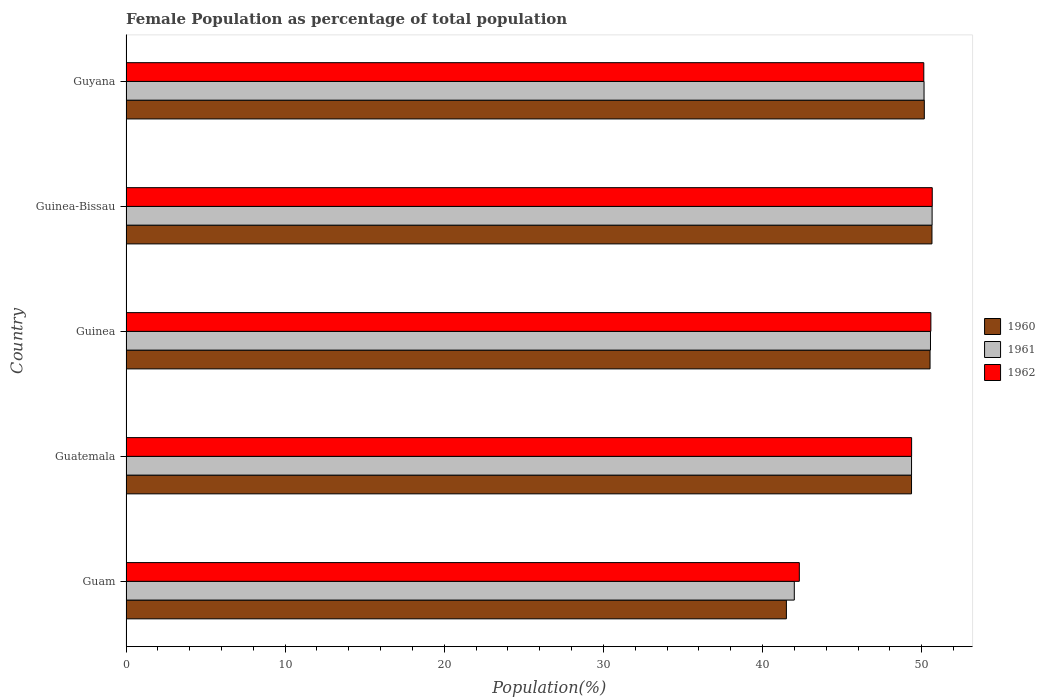How many groups of bars are there?
Ensure brevity in your answer.  5. How many bars are there on the 2nd tick from the bottom?
Give a very brief answer. 3. What is the label of the 3rd group of bars from the top?
Ensure brevity in your answer.  Guinea. What is the female population in in 1960 in Guam?
Your answer should be very brief. 41.5. Across all countries, what is the maximum female population in in 1962?
Your answer should be very brief. 50.66. Across all countries, what is the minimum female population in in 1961?
Offer a very short reply. 42. In which country was the female population in in 1962 maximum?
Your answer should be compact. Guinea-Bissau. In which country was the female population in in 1960 minimum?
Give a very brief answer. Guam. What is the total female population in in 1960 in the graph?
Provide a short and direct response. 242.2. What is the difference between the female population in in 1962 in Guatemala and that in Guyana?
Ensure brevity in your answer.  -0.77. What is the difference between the female population in in 1960 in Guam and the female population in in 1962 in Guinea?
Your answer should be compact. -9.08. What is the average female population in in 1962 per country?
Your response must be concise. 48.61. What is the difference between the female population in in 1961 and female population in in 1960 in Guam?
Provide a short and direct response. 0.5. What is the ratio of the female population in in 1961 in Guam to that in Guinea-Bissau?
Your answer should be very brief. 0.83. Is the female population in in 1962 in Guinea-Bissau less than that in Guyana?
Ensure brevity in your answer.  No. Is the difference between the female population in in 1961 in Guinea-Bissau and Guyana greater than the difference between the female population in in 1960 in Guinea-Bissau and Guyana?
Offer a very short reply. Yes. What is the difference between the highest and the second highest female population in in 1962?
Offer a terse response. 0.09. What is the difference between the highest and the lowest female population in in 1962?
Your answer should be compact. 8.35. Is the sum of the female population in in 1961 in Guinea and Guyana greater than the maximum female population in in 1962 across all countries?
Make the answer very short. Yes. What does the 3rd bar from the bottom in Guatemala represents?
Provide a short and direct response. 1962. How many bars are there?
Keep it short and to the point. 15. Are all the bars in the graph horizontal?
Provide a succinct answer. Yes. What is the difference between two consecutive major ticks on the X-axis?
Your answer should be very brief. 10. Are the values on the major ticks of X-axis written in scientific E-notation?
Give a very brief answer. No. What is the title of the graph?
Offer a terse response. Female Population as percentage of total population. What is the label or title of the X-axis?
Your answer should be compact. Population(%). What is the label or title of the Y-axis?
Offer a very short reply. Country. What is the Population(%) in 1960 in Guam?
Make the answer very short. 41.5. What is the Population(%) of 1961 in Guam?
Ensure brevity in your answer.  42. What is the Population(%) in 1962 in Guam?
Provide a succinct answer. 42.31. What is the Population(%) in 1960 in Guatemala?
Offer a terse response. 49.36. What is the Population(%) in 1961 in Guatemala?
Ensure brevity in your answer.  49.36. What is the Population(%) in 1962 in Guatemala?
Offer a very short reply. 49.37. What is the Population(%) in 1960 in Guinea?
Offer a terse response. 50.53. What is the Population(%) in 1961 in Guinea?
Your answer should be compact. 50.55. What is the Population(%) in 1962 in Guinea?
Your response must be concise. 50.58. What is the Population(%) in 1960 in Guinea-Bissau?
Ensure brevity in your answer.  50.65. What is the Population(%) of 1961 in Guinea-Bissau?
Your response must be concise. 50.66. What is the Population(%) of 1962 in Guinea-Bissau?
Your response must be concise. 50.66. What is the Population(%) of 1960 in Guyana?
Your answer should be compact. 50.17. What is the Population(%) in 1961 in Guyana?
Ensure brevity in your answer.  50.15. What is the Population(%) in 1962 in Guyana?
Your response must be concise. 50.13. Across all countries, what is the maximum Population(%) in 1960?
Give a very brief answer. 50.65. Across all countries, what is the maximum Population(%) of 1961?
Give a very brief answer. 50.66. Across all countries, what is the maximum Population(%) in 1962?
Ensure brevity in your answer.  50.66. Across all countries, what is the minimum Population(%) in 1960?
Your answer should be very brief. 41.5. Across all countries, what is the minimum Population(%) of 1961?
Offer a very short reply. 42. Across all countries, what is the minimum Population(%) in 1962?
Your answer should be compact. 42.31. What is the total Population(%) of 1960 in the graph?
Your answer should be very brief. 242.2. What is the total Population(%) in 1961 in the graph?
Give a very brief answer. 242.72. What is the total Population(%) of 1962 in the graph?
Your answer should be compact. 243.06. What is the difference between the Population(%) of 1960 in Guam and that in Guatemala?
Keep it short and to the point. -7.86. What is the difference between the Population(%) in 1961 in Guam and that in Guatemala?
Your response must be concise. -7.37. What is the difference between the Population(%) in 1962 in Guam and that in Guatemala?
Your answer should be compact. -7.06. What is the difference between the Population(%) of 1960 in Guam and that in Guinea?
Ensure brevity in your answer.  -9.03. What is the difference between the Population(%) in 1961 in Guam and that in Guinea?
Your answer should be very brief. -8.56. What is the difference between the Population(%) in 1962 in Guam and that in Guinea?
Make the answer very short. -8.27. What is the difference between the Population(%) of 1960 in Guam and that in Guinea-Bissau?
Your answer should be very brief. -9.15. What is the difference between the Population(%) in 1961 in Guam and that in Guinea-Bissau?
Ensure brevity in your answer.  -8.66. What is the difference between the Population(%) in 1962 in Guam and that in Guinea-Bissau?
Make the answer very short. -8.35. What is the difference between the Population(%) of 1960 in Guam and that in Guyana?
Offer a terse response. -8.67. What is the difference between the Population(%) in 1961 in Guam and that in Guyana?
Offer a terse response. -8.15. What is the difference between the Population(%) in 1962 in Guam and that in Guyana?
Offer a terse response. -7.82. What is the difference between the Population(%) of 1960 in Guatemala and that in Guinea?
Offer a terse response. -1.16. What is the difference between the Population(%) in 1961 in Guatemala and that in Guinea?
Provide a succinct answer. -1.19. What is the difference between the Population(%) of 1962 in Guatemala and that in Guinea?
Your response must be concise. -1.21. What is the difference between the Population(%) in 1960 in Guatemala and that in Guinea-Bissau?
Your response must be concise. -1.28. What is the difference between the Population(%) of 1961 in Guatemala and that in Guinea-Bissau?
Your response must be concise. -1.29. What is the difference between the Population(%) of 1962 in Guatemala and that in Guinea-Bissau?
Make the answer very short. -1.3. What is the difference between the Population(%) in 1960 in Guatemala and that in Guyana?
Offer a terse response. -0.8. What is the difference between the Population(%) in 1961 in Guatemala and that in Guyana?
Give a very brief answer. -0.79. What is the difference between the Population(%) in 1962 in Guatemala and that in Guyana?
Provide a succinct answer. -0.77. What is the difference between the Population(%) in 1960 in Guinea and that in Guinea-Bissau?
Provide a short and direct response. -0.12. What is the difference between the Population(%) of 1961 in Guinea and that in Guinea-Bissau?
Ensure brevity in your answer.  -0.1. What is the difference between the Population(%) of 1962 in Guinea and that in Guinea-Bissau?
Ensure brevity in your answer.  -0.09. What is the difference between the Population(%) of 1960 in Guinea and that in Guyana?
Keep it short and to the point. 0.36. What is the difference between the Population(%) in 1961 in Guinea and that in Guyana?
Your response must be concise. 0.4. What is the difference between the Population(%) in 1962 in Guinea and that in Guyana?
Offer a terse response. 0.45. What is the difference between the Population(%) in 1960 in Guinea-Bissau and that in Guyana?
Your answer should be very brief. 0.48. What is the difference between the Population(%) of 1961 in Guinea-Bissau and that in Guyana?
Provide a succinct answer. 0.51. What is the difference between the Population(%) of 1962 in Guinea-Bissau and that in Guyana?
Give a very brief answer. 0.53. What is the difference between the Population(%) of 1960 in Guam and the Population(%) of 1961 in Guatemala?
Offer a terse response. -7.87. What is the difference between the Population(%) of 1960 in Guam and the Population(%) of 1962 in Guatemala?
Keep it short and to the point. -7.87. What is the difference between the Population(%) in 1961 in Guam and the Population(%) in 1962 in Guatemala?
Offer a very short reply. -7.37. What is the difference between the Population(%) of 1960 in Guam and the Population(%) of 1961 in Guinea?
Make the answer very short. -9.06. What is the difference between the Population(%) of 1960 in Guam and the Population(%) of 1962 in Guinea?
Your answer should be compact. -9.08. What is the difference between the Population(%) of 1961 in Guam and the Population(%) of 1962 in Guinea?
Your response must be concise. -8.58. What is the difference between the Population(%) of 1960 in Guam and the Population(%) of 1961 in Guinea-Bissau?
Your answer should be very brief. -9.16. What is the difference between the Population(%) in 1960 in Guam and the Population(%) in 1962 in Guinea-Bissau?
Offer a terse response. -9.17. What is the difference between the Population(%) in 1961 in Guam and the Population(%) in 1962 in Guinea-Bissau?
Keep it short and to the point. -8.67. What is the difference between the Population(%) in 1960 in Guam and the Population(%) in 1961 in Guyana?
Your answer should be compact. -8.65. What is the difference between the Population(%) of 1960 in Guam and the Population(%) of 1962 in Guyana?
Give a very brief answer. -8.63. What is the difference between the Population(%) in 1961 in Guam and the Population(%) in 1962 in Guyana?
Your answer should be compact. -8.14. What is the difference between the Population(%) of 1960 in Guatemala and the Population(%) of 1961 in Guinea?
Keep it short and to the point. -1.19. What is the difference between the Population(%) in 1960 in Guatemala and the Population(%) in 1962 in Guinea?
Your answer should be compact. -1.22. What is the difference between the Population(%) in 1961 in Guatemala and the Population(%) in 1962 in Guinea?
Your response must be concise. -1.21. What is the difference between the Population(%) in 1960 in Guatemala and the Population(%) in 1961 in Guinea-Bissau?
Your answer should be very brief. -1.29. What is the difference between the Population(%) of 1960 in Guatemala and the Population(%) of 1962 in Guinea-Bissau?
Your response must be concise. -1.3. What is the difference between the Population(%) in 1961 in Guatemala and the Population(%) in 1962 in Guinea-Bissau?
Make the answer very short. -1.3. What is the difference between the Population(%) in 1960 in Guatemala and the Population(%) in 1961 in Guyana?
Offer a very short reply. -0.79. What is the difference between the Population(%) in 1960 in Guatemala and the Population(%) in 1962 in Guyana?
Your response must be concise. -0.77. What is the difference between the Population(%) of 1961 in Guatemala and the Population(%) of 1962 in Guyana?
Offer a very short reply. -0.77. What is the difference between the Population(%) of 1960 in Guinea and the Population(%) of 1961 in Guinea-Bissau?
Your answer should be very brief. -0.13. What is the difference between the Population(%) in 1960 in Guinea and the Population(%) in 1962 in Guinea-Bissau?
Keep it short and to the point. -0.14. What is the difference between the Population(%) in 1961 in Guinea and the Population(%) in 1962 in Guinea-Bissau?
Offer a very short reply. -0.11. What is the difference between the Population(%) in 1960 in Guinea and the Population(%) in 1961 in Guyana?
Provide a short and direct response. 0.38. What is the difference between the Population(%) of 1960 in Guinea and the Population(%) of 1962 in Guyana?
Ensure brevity in your answer.  0.39. What is the difference between the Population(%) in 1961 in Guinea and the Population(%) in 1962 in Guyana?
Provide a succinct answer. 0.42. What is the difference between the Population(%) in 1960 in Guinea-Bissau and the Population(%) in 1961 in Guyana?
Give a very brief answer. 0.5. What is the difference between the Population(%) of 1960 in Guinea-Bissau and the Population(%) of 1962 in Guyana?
Provide a short and direct response. 0.51. What is the difference between the Population(%) in 1961 in Guinea-Bissau and the Population(%) in 1962 in Guyana?
Your response must be concise. 0.52. What is the average Population(%) of 1960 per country?
Your answer should be compact. 48.44. What is the average Population(%) in 1961 per country?
Give a very brief answer. 48.54. What is the average Population(%) in 1962 per country?
Your answer should be very brief. 48.61. What is the difference between the Population(%) in 1960 and Population(%) in 1961 in Guam?
Give a very brief answer. -0.5. What is the difference between the Population(%) of 1960 and Population(%) of 1962 in Guam?
Offer a terse response. -0.81. What is the difference between the Population(%) of 1961 and Population(%) of 1962 in Guam?
Keep it short and to the point. -0.32. What is the difference between the Population(%) of 1960 and Population(%) of 1961 in Guatemala?
Make the answer very short. -0. What is the difference between the Population(%) in 1960 and Population(%) in 1962 in Guatemala?
Your answer should be compact. -0. What is the difference between the Population(%) in 1961 and Population(%) in 1962 in Guatemala?
Your answer should be very brief. -0. What is the difference between the Population(%) in 1960 and Population(%) in 1961 in Guinea?
Ensure brevity in your answer.  -0.03. What is the difference between the Population(%) in 1960 and Population(%) in 1962 in Guinea?
Ensure brevity in your answer.  -0.05. What is the difference between the Population(%) in 1961 and Population(%) in 1962 in Guinea?
Your answer should be compact. -0.02. What is the difference between the Population(%) of 1960 and Population(%) of 1961 in Guinea-Bissau?
Your response must be concise. -0.01. What is the difference between the Population(%) of 1960 and Population(%) of 1962 in Guinea-Bissau?
Your response must be concise. -0.02. What is the difference between the Population(%) in 1961 and Population(%) in 1962 in Guinea-Bissau?
Ensure brevity in your answer.  -0.01. What is the difference between the Population(%) in 1960 and Population(%) in 1961 in Guyana?
Your answer should be very brief. 0.02. What is the difference between the Population(%) in 1960 and Population(%) in 1962 in Guyana?
Provide a short and direct response. 0.03. What is the difference between the Population(%) of 1961 and Population(%) of 1962 in Guyana?
Ensure brevity in your answer.  0.02. What is the ratio of the Population(%) in 1960 in Guam to that in Guatemala?
Offer a terse response. 0.84. What is the ratio of the Population(%) of 1961 in Guam to that in Guatemala?
Give a very brief answer. 0.85. What is the ratio of the Population(%) in 1962 in Guam to that in Guatemala?
Keep it short and to the point. 0.86. What is the ratio of the Population(%) of 1960 in Guam to that in Guinea?
Offer a terse response. 0.82. What is the ratio of the Population(%) in 1961 in Guam to that in Guinea?
Your answer should be compact. 0.83. What is the ratio of the Population(%) in 1962 in Guam to that in Guinea?
Offer a terse response. 0.84. What is the ratio of the Population(%) in 1960 in Guam to that in Guinea-Bissau?
Keep it short and to the point. 0.82. What is the ratio of the Population(%) in 1961 in Guam to that in Guinea-Bissau?
Ensure brevity in your answer.  0.83. What is the ratio of the Population(%) in 1962 in Guam to that in Guinea-Bissau?
Make the answer very short. 0.84. What is the ratio of the Population(%) of 1960 in Guam to that in Guyana?
Your answer should be very brief. 0.83. What is the ratio of the Population(%) of 1961 in Guam to that in Guyana?
Your response must be concise. 0.84. What is the ratio of the Population(%) in 1962 in Guam to that in Guyana?
Your response must be concise. 0.84. What is the ratio of the Population(%) of 1961 in Guatemala to that in Guinea?
Provide a succinct answer. 0.98. What is the ratio of the Population(%) in 1962 in Guatemala to that in Guinea?
Offer a terse response. 0.98. What is the ratio of the Population(%) in 1960 in Guatemala to that in Guinea-Bissau?
Offer a very short reply. 0.97. What is the ratio of the Population(%) of 1961 in Guatemala to that in Guinea-Bissau?
Offer a terse response. 0.97. What is the ratio of the Population(%) of 1962 in Guatemala to that in Guinea-Bissau?
Make the answer very short. 0.97. What is the ratio of the Population(%) in 1961 in Guatemala to that in Guyana?
Offer a terse response. 0.98. What is the ratio of the Population(%) in 1962 in Guatemala to that in Guyana?
Offer a terse response. 0.98. What is the ratio of the Population(%) of 1961 in Guinea to that in Guinea-Bissau?
Provide a succinct answer. 1. What is the ratio of the Population(%) in 1961 in Guinea to that in Guyana?
Make the answer very short. 1.01. What is the ratio of the Population(%) of 1962 in Guinea to that in Guyana?
Keep it short and to the point. 1.01. What is the ratio of the Population(%) in 1960 in Guinea-Bissau to that in Guyana?
Provide a short and direct response. 1.01. What is the ratio of the Population(%) of 1962 in Guinea-Bissau to that in Guyana?
Your answer should be compact. 1.01. What is the difference between the highest and the second highest Population(%) of 1960?
Provide a short and direct response. 0.12. What is the difference between the highest and the second highest Population(%) in 1961?
Provide a short and direct response. 0.1. What is the difference between the highest and the second highest Population(%) of 1962?
Your answer should be very brief. 0.09. What is the difference between the highest and the lowest Population(%) in 1960?
Your answer should be very brief. 9.15. What is the difference between the highest and the lowest Population(%) of 1961?
Offer a very short reply. 8.66. What is the difference between the highest and the lowest Population(%) of 1962?
Give a very brief answer. 8.35. 